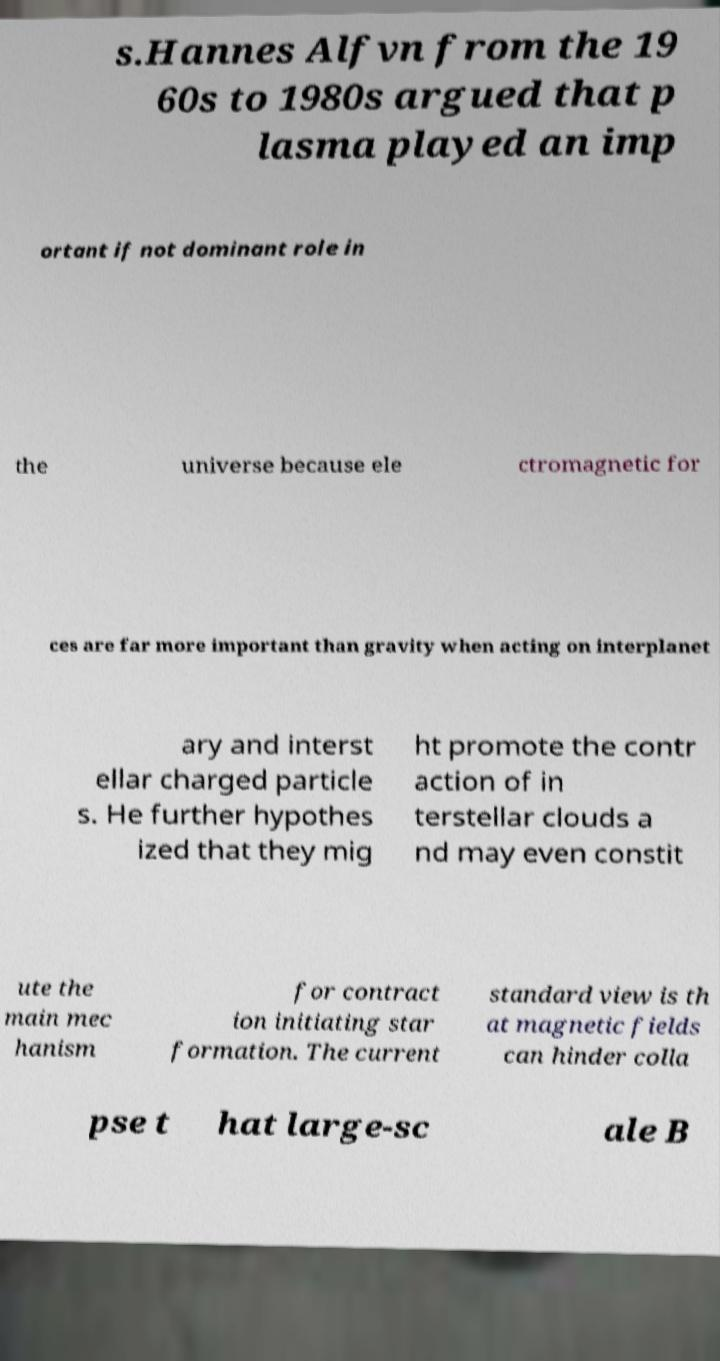Could you extract and type out the text from this image? s.Hannes Alfvn from the 19 60s to 1980s argued that p lasma played an imp ortant if not dominant role in the universe because ele ctromagnetic for ces are far more important than gravity when acting on interplanet ary and interst ellar charged particle s. He further hypothes ized that they mig ht promote the contr action of in terstellar clouds a nd may even constit ute the main mec hanism for contract ion initiating star formation. The current standard view is th at magnetic fields can hinder colla pse t hat large-sc ale B 